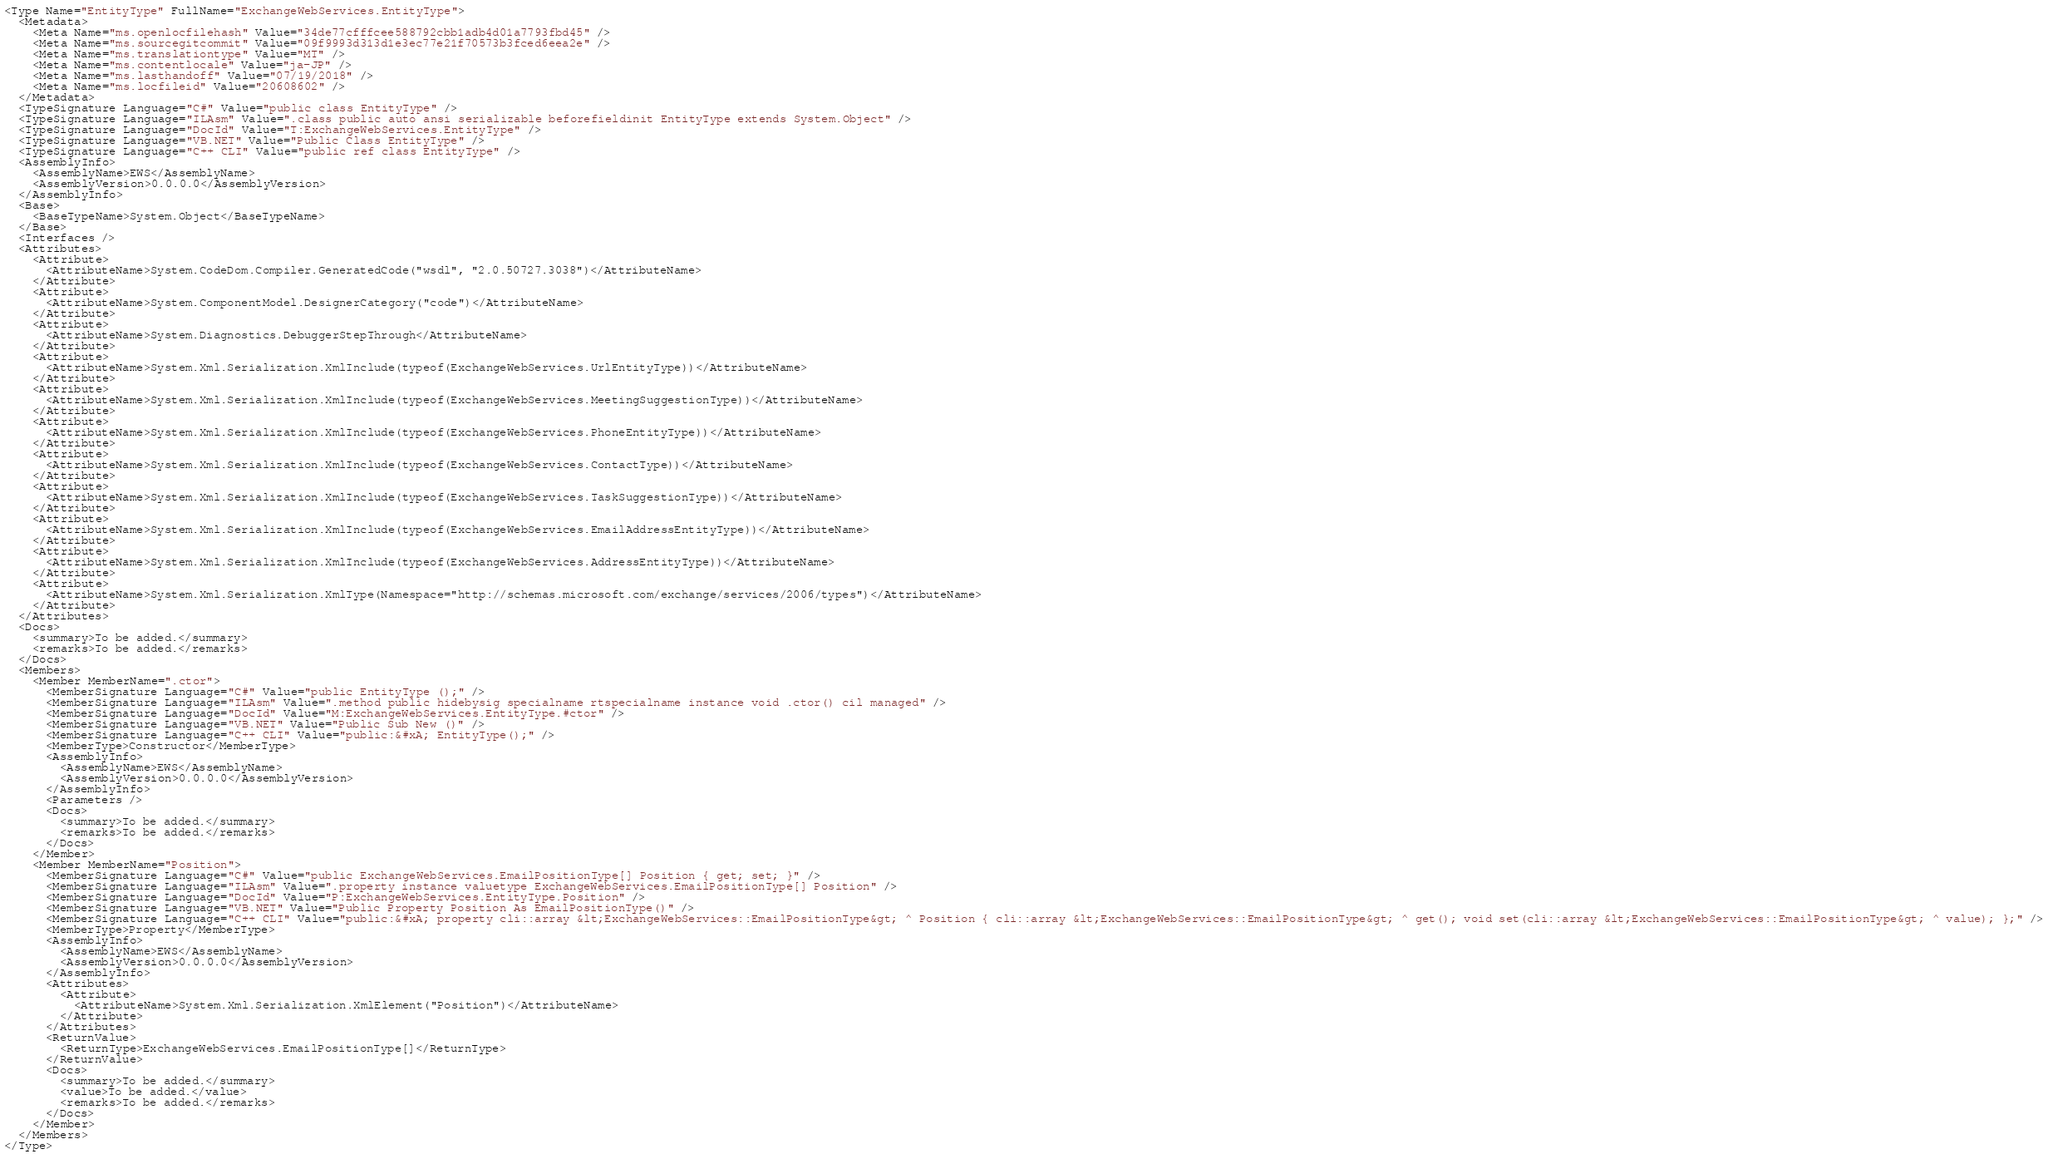<code> <loc_0><loc_0><loc_500><loc_500><_XML_><Type Name="EntityType" FullName="ExchangeWebServices.EntityType">
  <Metadata>
    <Meta Name="ms.openlocfilehash" Value="34de77cfffcee588792cbb1adb4d01a7793fbd45" />
    <Meta Name="ms.sourcegitcommit" Value="09f9993d313d1e3ec77e21f70573b3fced6eea2e" />
    <Meta Name="ms.translationtype" Value="MT" />
    <Meta Name="ms.contentlocale" Value="ja-JP" />
    <Meta Name="ms.lasthandoff" Value="07/19/2018" />
    <Meta Name="ms.locfileid" Value="20608602" />
  </Metadata>
  <TypeSignature Language="C#" Value="public class EntityType" />
  <TypeSignature Language="ILAsm" Value=".class public auto ansi serializable beforefieldinit EntityType extends System.Object" />
  <TypeSignature Language="DocId" Value="T:ExchangeWebServices.EntityType" />
  <TypeSignature Language="VB.NET" Value="Public Class EntityType" />
  <TypeSignature Language="C++ CLI" Value="public ref class EntityType" />
  <AssemblyInfo>
    <AssemblyName>EWS</AssemblyName>
    <AssemblyVersion>0.0.0.0</AssemblyVersion>
  </AssemblyInfo>
  <Base>
    <BaseTypeName>System.Object</BaseTypeName>
  </Base>
  <Interfaces />
  <Attributes>
    <Attribute>
      <AttributeName>System.CodeDom.Compiler.GeneratedCode("wsdl", "2.0.50727.3038")</AttributeName>
    </Attribute>
    <Attribute>
      <AttributeName>System.ComponentModel.DesignerCategory("code")</AttributeName>
    </Attribute>
    <Attribute>
      <AttributeName>System.Diagnostics.DebuggerStepThrough</AttributeName>
    </Attribute>
    <Attribute>
      <AttributeName>System.Xml.Serialization.XmlInclude(typeof(ExchangeWebServices.UrlEntityType))</AttributeName>
    </Attribute>
    <Attribute>
      <AttributeName>System.Xml.Serialization.XmlInclude(typeof(ExchangeWebServices.MeetingSuggestionType))</AttributeName>
    </Attribute>
    <Attribute>
      <AttributeName>System.Xml.Serialization.XmlInclude(typeof(ExchangeWebServices.PhoneEntityType))</AttributeName>
    </Attribute>
    <Attribute>
      <AttributeName>System.Xml.Serialization.XmlInclude(typeof(ExchangeWebServices.ContactType))</AttributeName>
    </Attribute>
    <Attribute>
      <AttributeName>System.Xml.Serialization.XmlInclude(typeof(ExchangeWebServices.TaskSuggestionType))</AttributeName>
    </Attribute>
    <Attribute>
      <AttributeName>System.Xml.Serialization.XmlInclude(typeof(ExchangeWebServices.EmailAddressEntityType))</AttributeName>
    </Attribute>
    <Attribute>
      <AttributeName>System.Xml.Serialization.XmlInclude(typeof(ExchangeWebServices.AddressEntityType))</AttributeName>
    </Attribute>
    <Attribute>
      <AttributeName>System.Xml.Serialization.XmlType(Namespace="http://schemas.microsoft.com/exchange/services/2006/types")</AttributeName>
    </Attribute>
  </Attributes>
  <Docs>
    <summary>To be added.</summary>
    <remarks>To be added.</remarks>
  </Docs>
  <Members>
    <Member MemberName=".ctor">
      <MemberSignature Language="C#" Value="public EntityType ();" />
      <MemberSignature Language="ILAsm" Value=".method public hidebysig specialname rtspecialname instance void .ctor() cil managed" />
      <MemberSignature Language="DocId" Value="M:ExchangeWebServices.EntityType.#ctor" />
      <MemberSignature Language="VB.NET" Value="Public Sub New ()" />
      <MemberSignature Language="C++ CLI" Value="public:&#xA; EntityType();" />
      <MemberType>Constructor</MemberType>
      <AssemblyInfo>
        <AssemblyName>EWS</AssemblyName>
        <AssemblyVersion>0.0.0.0</AssemblyVersion>
      </AssemblyInfo>
      <Parameters />
      <Docs>
        <summary>To be added.</summary>
        <remarks>To be added.</remarks>
      </Docs>
    </Member>
    <Member MemberName="Position">
      <MemberSignature Language="C#" Value="public ExchangeWebServices.EmailPositionType[] Position { get; set; }" />
      <MemberSignature Language="ILAsm" Value=".property instance valuetype ExchangeWebServices.EmailPositionType[] Position" />
      <MemberSignature Language="DocId" Value="P:ExchangeWebServices.EntityType.Position" />
      <MemberSignature Language="VB.NET" Value="Public Property Position As EmailPositionType()" />
      <MemberSignature Language="C++ CLI" Value="public:&#xA; property cli::array &lt;ExchangeWebServices::EmailPositionType&gt; ^ Position { cli::array &lt;ExchangeWebServices::EmailPositionType&gt; ^ get(); void set(cli::array &lt;ExchangeWebServices::EmailPositionType&gt; ^ value); };" />
      <MemberType>Property</MemberType>
      <AssemblyInfo>
        <AssemblyName>EWS</AssemblyName>
        <AssemblyVersion>0.0.0.0</AssemblyVersion>
      </AssemblyInfo>
      <Attributes>
        <Attribute>
          <AttributeName>System.Xml.Serialization.XmlElement("Position")</AttributeName>
        </Attribute>
      </Attributes>
      <ReturnValue>
        <ReturnType>ExchangeWebServices.EmailPositionType[]</ReturnType>
      </ReturnValue>
      <Docs>
        <summary>To be added.</summary>
        <value>To be added.</value>
        <remarks>To be added.</remarks>
      </Docs>
    </Member>
  </Members>
</Type></code> 